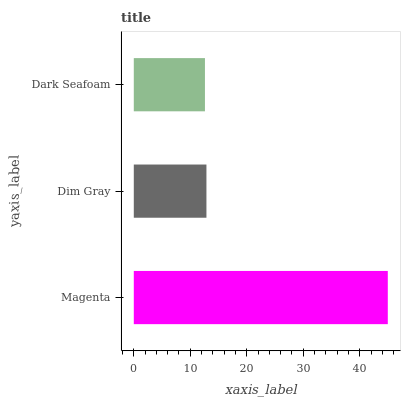Is Dark Seafoam the minimum?
Answer yes or no. Yes. Is Magenta the maximum?
Answer yes or no. Yes. Is Dim Gray the minimum?
Answer yes or no. No. Is Dim Gray the maximum?
Answer yes or no. No. Is Magenta greater than Dim Gray?
Answer yes or no. Yes. Is Dim Gray less than Magenta?
Answer yes or no. Yes. Is Dim Gray greater than Magenta?
Answer yes or no. No. Is Magenta less than Dim Gray?
Answer yes or no. No. Is Dim Gray the high median?
Answer yes or no. Yes. Is Dim Gray the low median?
Answer yes or no. Yes. Is Dark Seafoam the high median?
Answer yes or no. No. Is Magenta the low median?
Answer yes or no. No. 